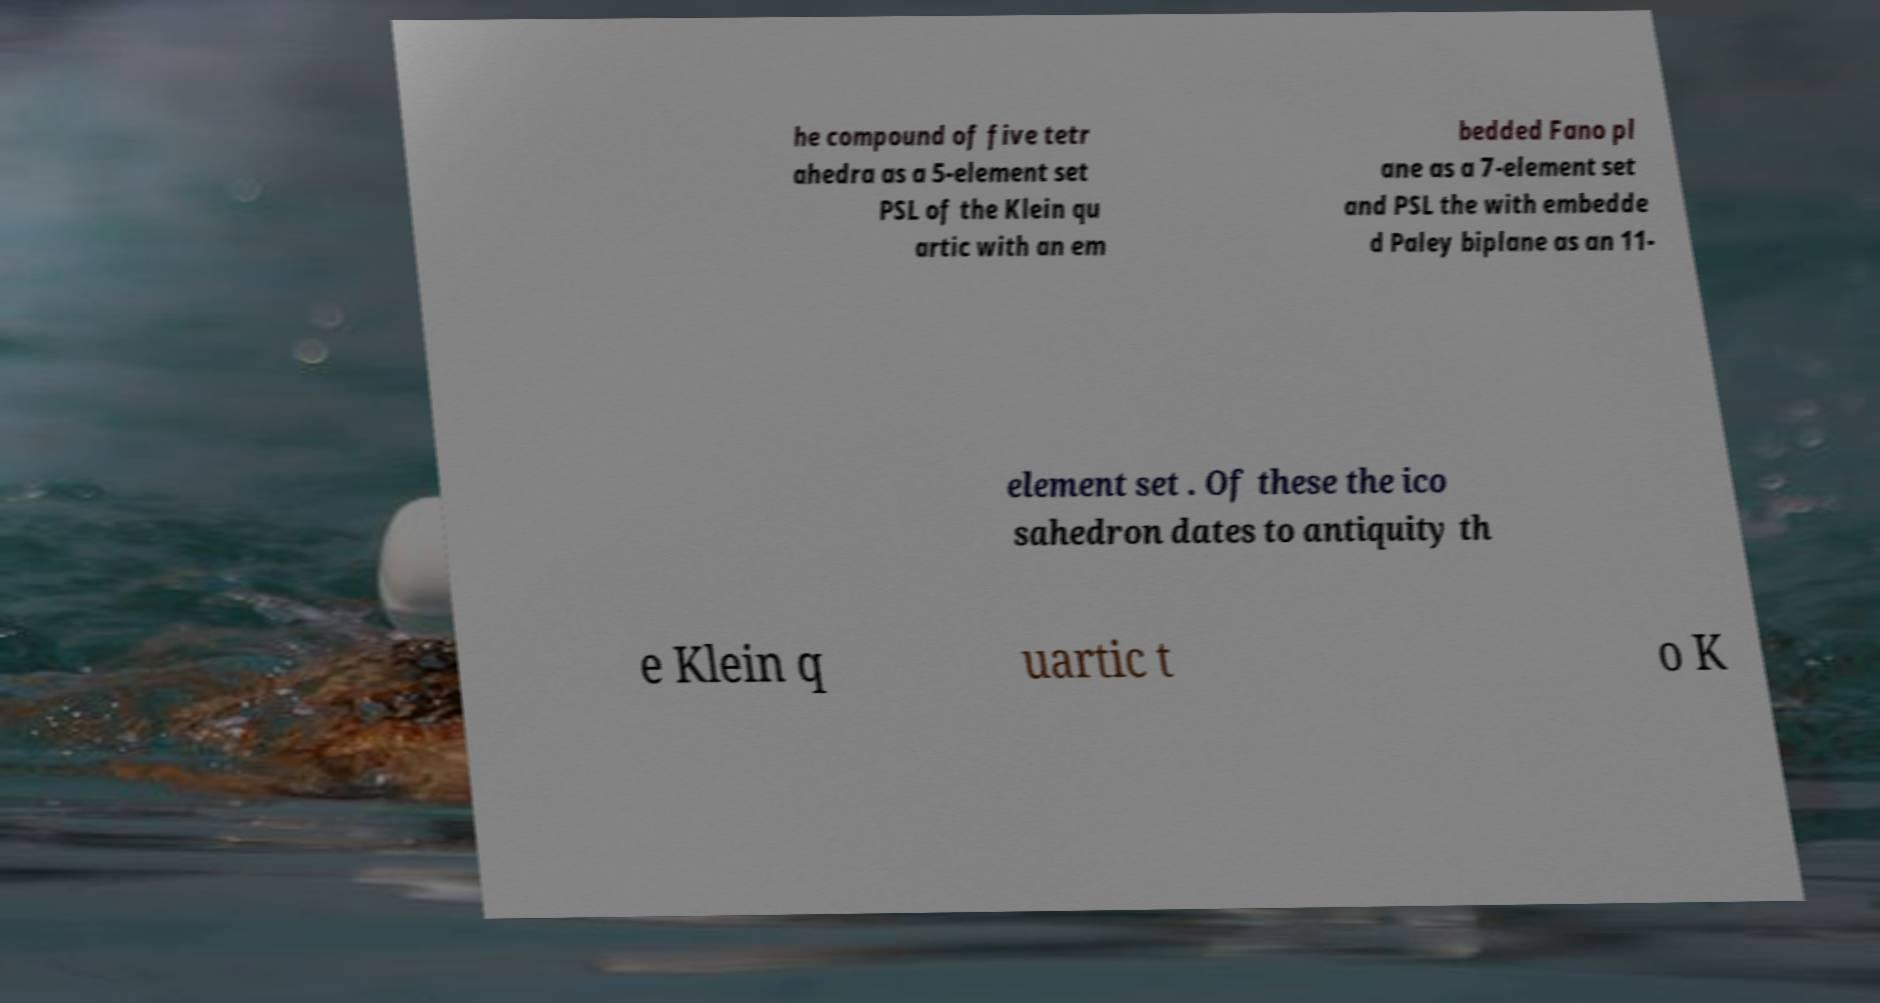There's text embedded in this image that I need extracted. Can you transcribe it verbatim? he compound of five tetr ahedra as a 5-element set PSL of the Klein qu artic with an em bedded Fano pl ane as a 7-element set and PSL the with embedde d Paley biplane as an 11- element set . Of these the ico sahedron dates to antiquity th e Klein q uartic t o K 